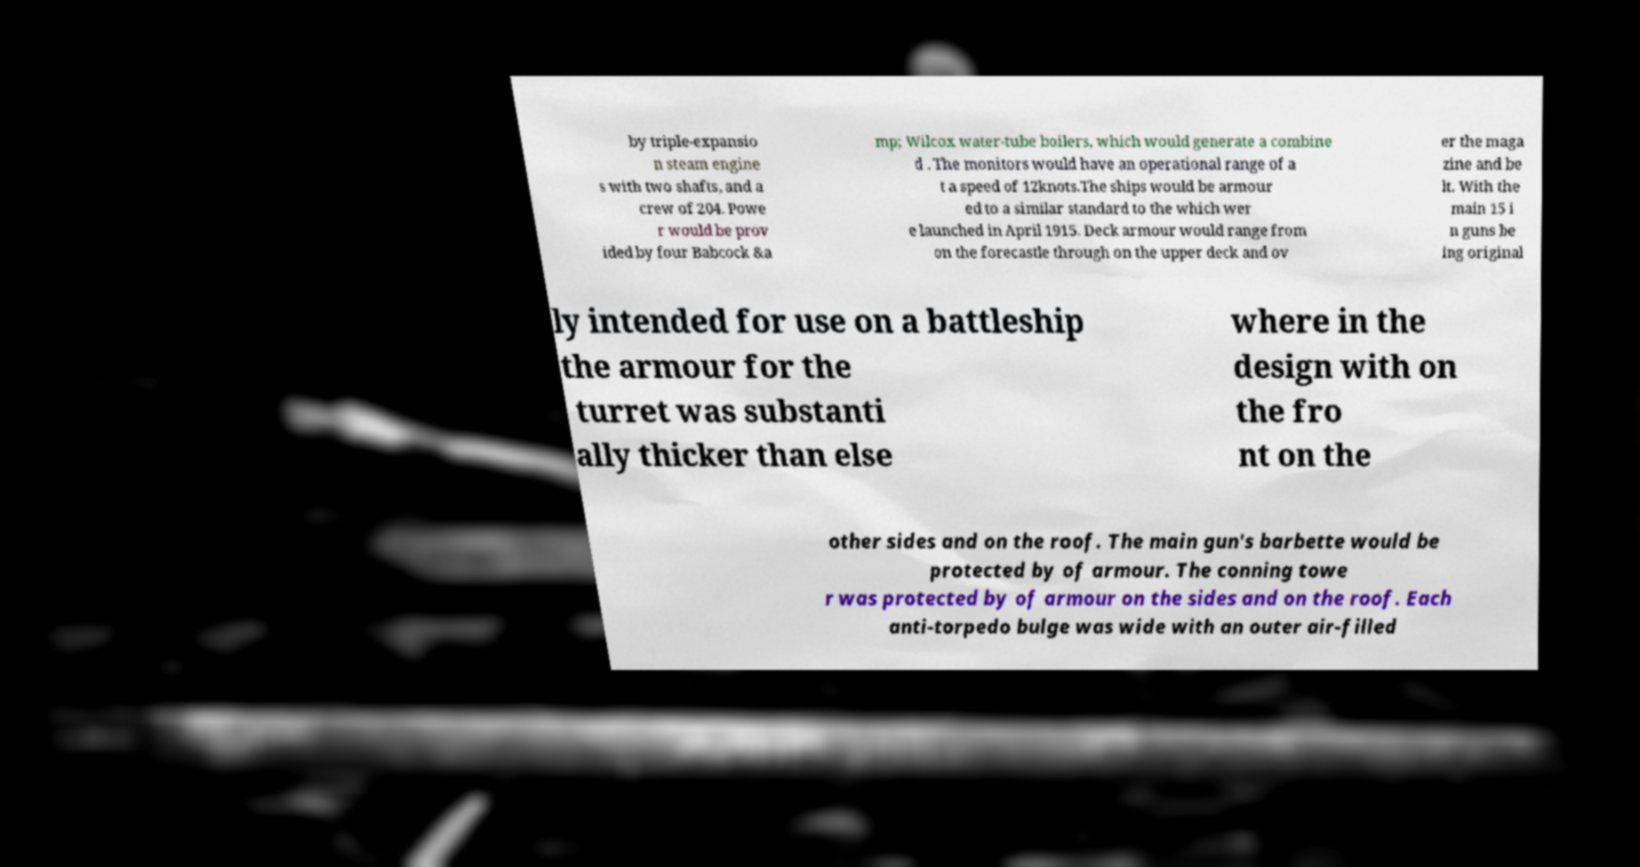Could you assist in decoding the text presented in this image and type it out clearly? by triple-expansio n steam engine s with two shafts, and a crew of 204. Powe r would be prov ided by four Babcock &a mp; Wilcox water-tube boilers, which would generate a combine d . The monitors would have an operational range of a t a speed of 12knots.The ships would be armour ed to a similar standard to the which wer e launched in April 1915. Deck armour would range from on the forecastle through on the upper deck and ov er the maga zine and be lt. With the main 15 i n guns be ing original ly intended for use on a battleship the armour for the turret was substanti ally thicker than else where in the design with on the fro nt on the other sides and on the roof. The main gun's barbette would be protected by of armour. The conning towe r was protected by of armour on the sides and on the roof. Each anti-torpedo bulge was wide with an outer air-filled 